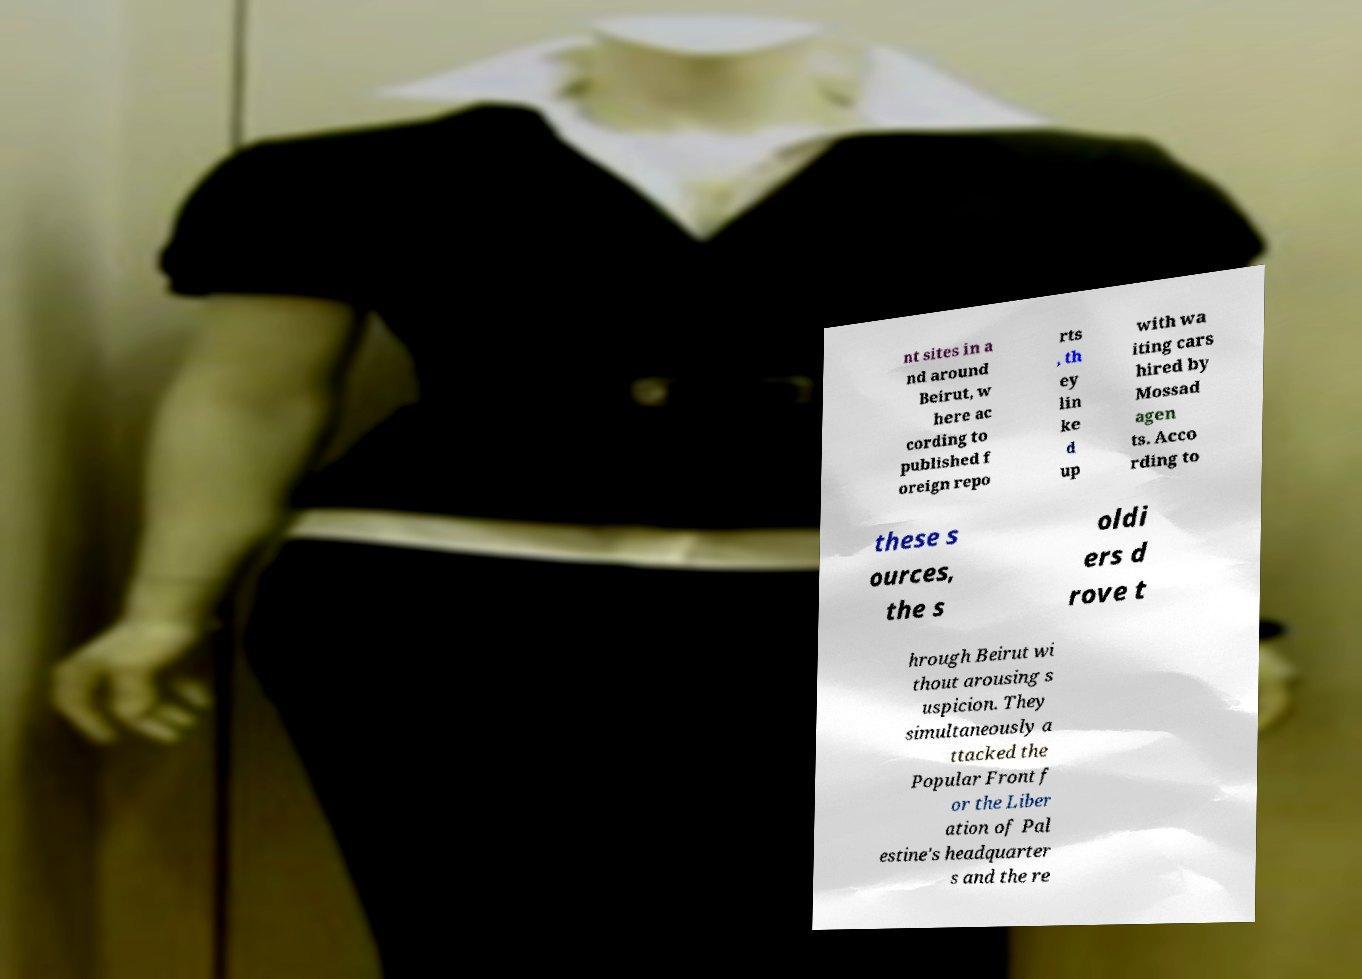Can you read and provide the text displayed in the image?This photo seems to have some interesting text. Can you extract and type it out for me? nt sites in a nd around Beirut, w here ac cording to published f oreign repo rts , th ey lin ke d up with wa iting cars hired by Mossad agen ts. Acco rding to these s ources, the s oldi ers d rove t hrough Beirut wi thout arousing s uspicion. They simultaneously a ttacked the Popular Front f or the Liber ation of Pal estine's headquarter s and the re 